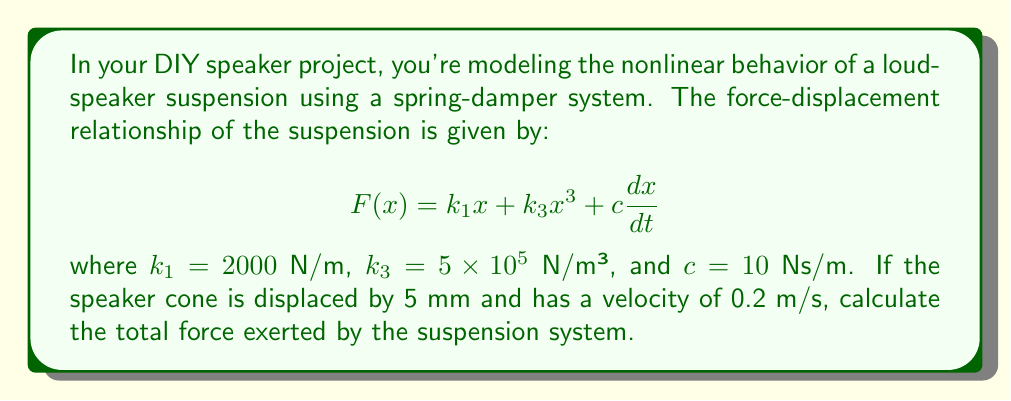Can you solve this math problem? To solve this problem, we'll follow these steps:

1) First, let's identify the given values:
   $k_1 = 2000$ N/m
   $k_3 = 5 \times 10^5$ N/m³
   $c = 10$ Ns/m
   $x = 5$ mm = $0.005$ m
   $\frac{dx}{dt} = 0.2$ m/s

2) Now, let's substitute these values into the force equation:

   $$F(x) = k_1x + k_3x^3 + c\frac{dx}{dt}$$

3) Calculate the linear spring force:
   $k_1x = 2000 \times 0.005 = 10$ N

4) Calculate the nonlinear spring force:
   $k_3x^3 = 5 \times 10^5 \times (0.005)^3 = 0.0625$ N

5) Calculate the damping force:
   $c\frac{dx}{dt} = 10 \times 0.2 = 2$ N

6) Sum up all the forces:
   $F_{total} = 10 + 0.0625 + 2 = 12.0625$ N

Therefore, the total force exerted by the suspension system is 12.0625 N.
Answer: 12.0625 N 